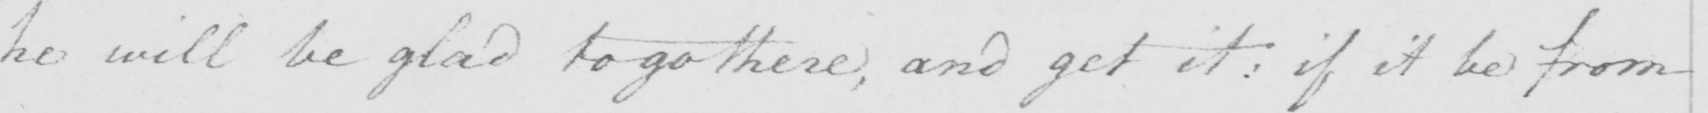Transcribe the text shown in this historical manuscript line. he will be glad to go there , and get it :  if it be from 